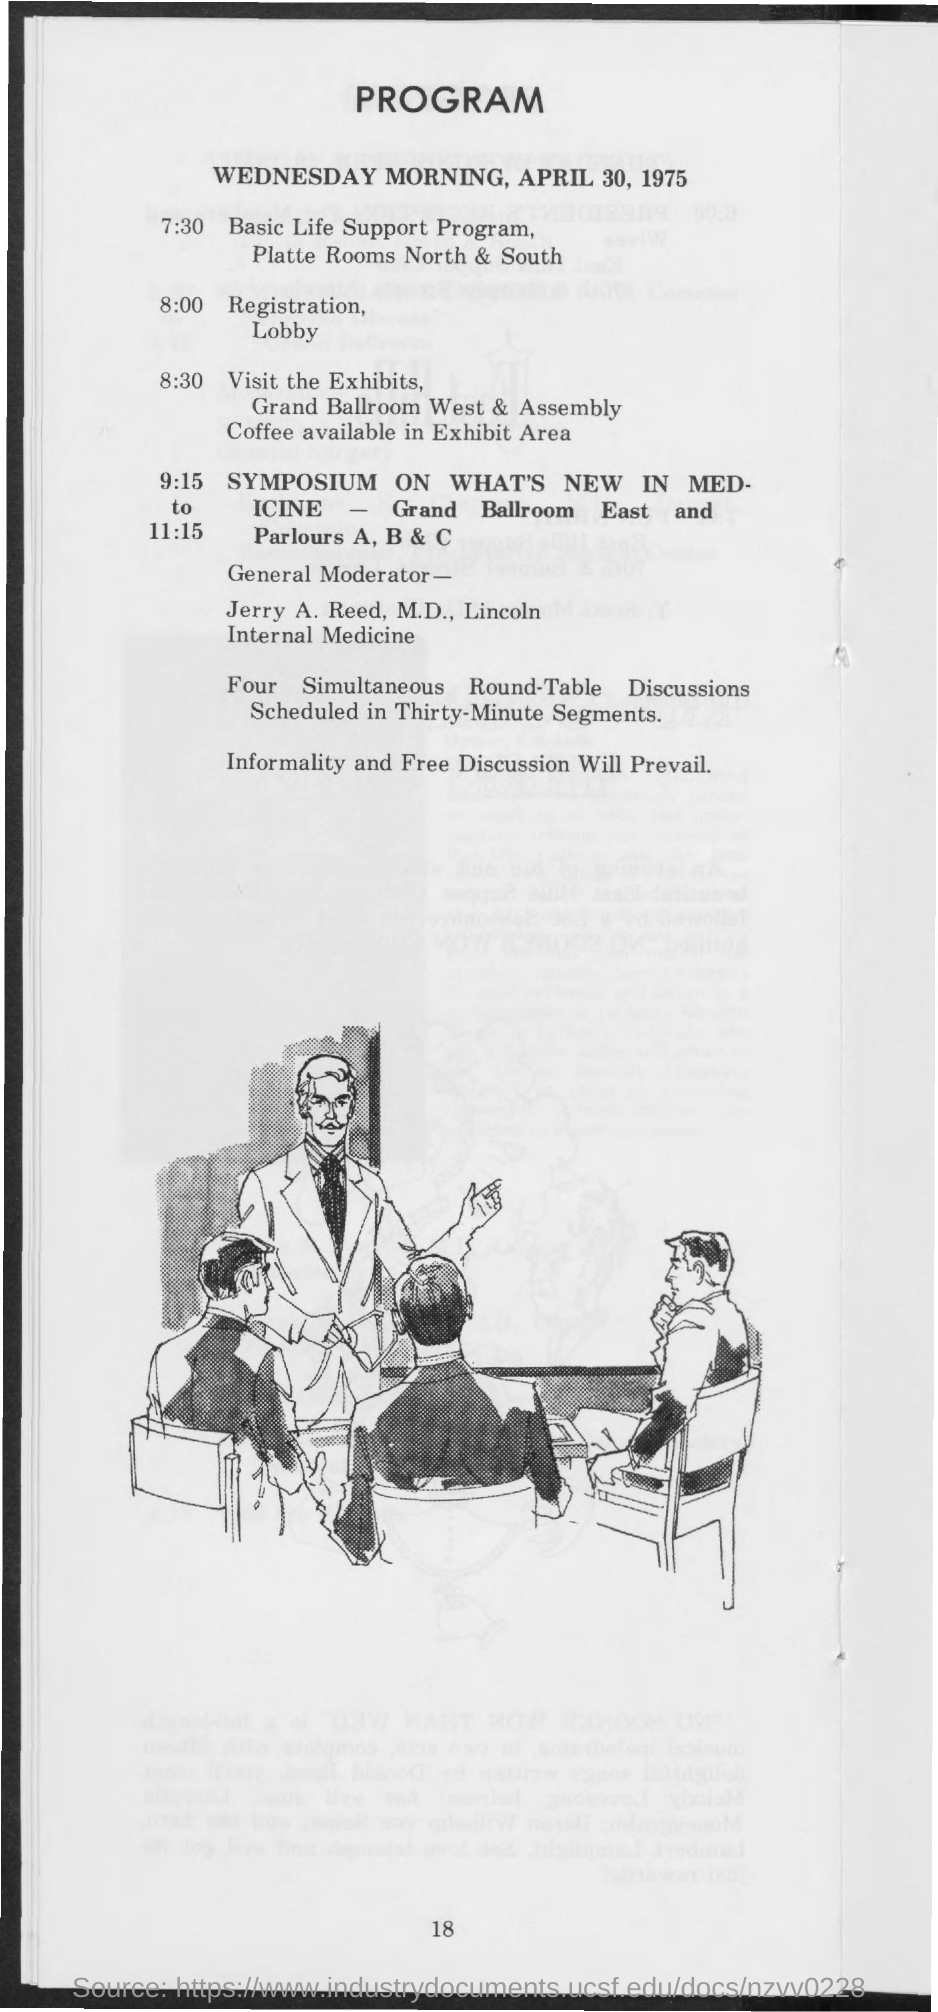Outline some significant characteristics in this image. At 7:30, a basic LFE support program is scheduled. This program belongs to the date of April 30, 1975. At 8:00, registration and the lobby are scheduled to take place. 